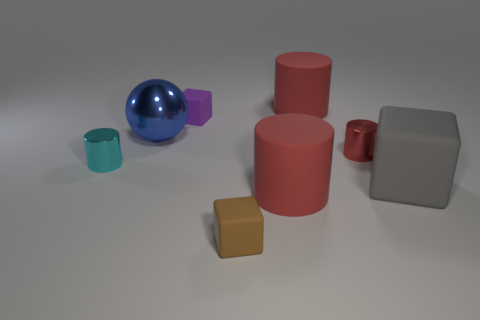Subtract all red cylinders. How many were subtracted if there are2red cylinders left? 1 Subtract all large blocks. How many blocks are left? 2 Subtract all brown balls. How many red cylinders are left? 3 Add 1 large yellow matte cubes. How many objects exist? 9 Subtract 1 cubes. How many cubes are left? 2 Subtract all cyan cylinders. How many cylinders are left? 3 Subtract all spheres. How many objects are left? 7 Subtract 0 brown cylinders. How many objects are left? 8 Subtract all brown spheres. Subtract all cyan cylinders. How many spheres are left? 1 Subtract all rubber cubes. Subtract all big rubber objects. How many objects are left? 2 